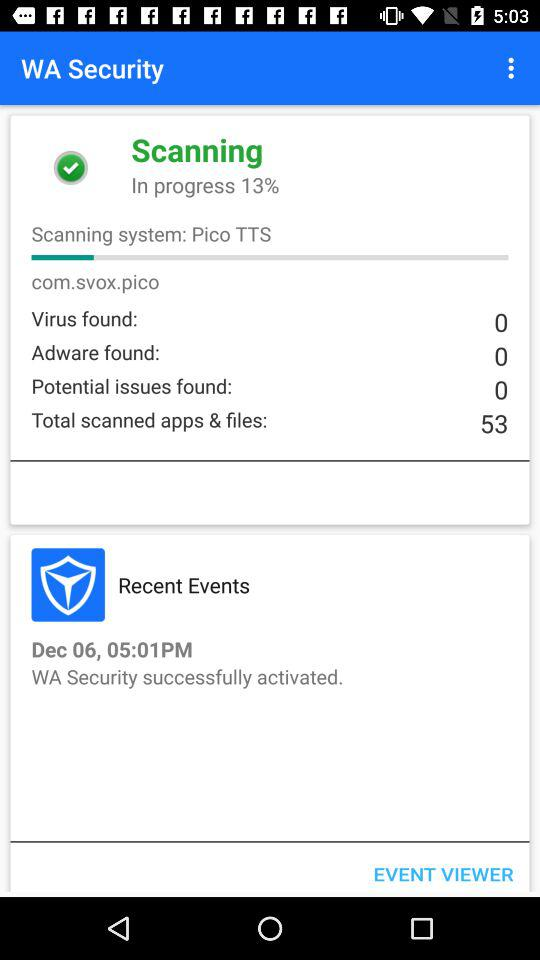How many more potential issues were found than adware?
Answer the question using a single word or phrase. 0 